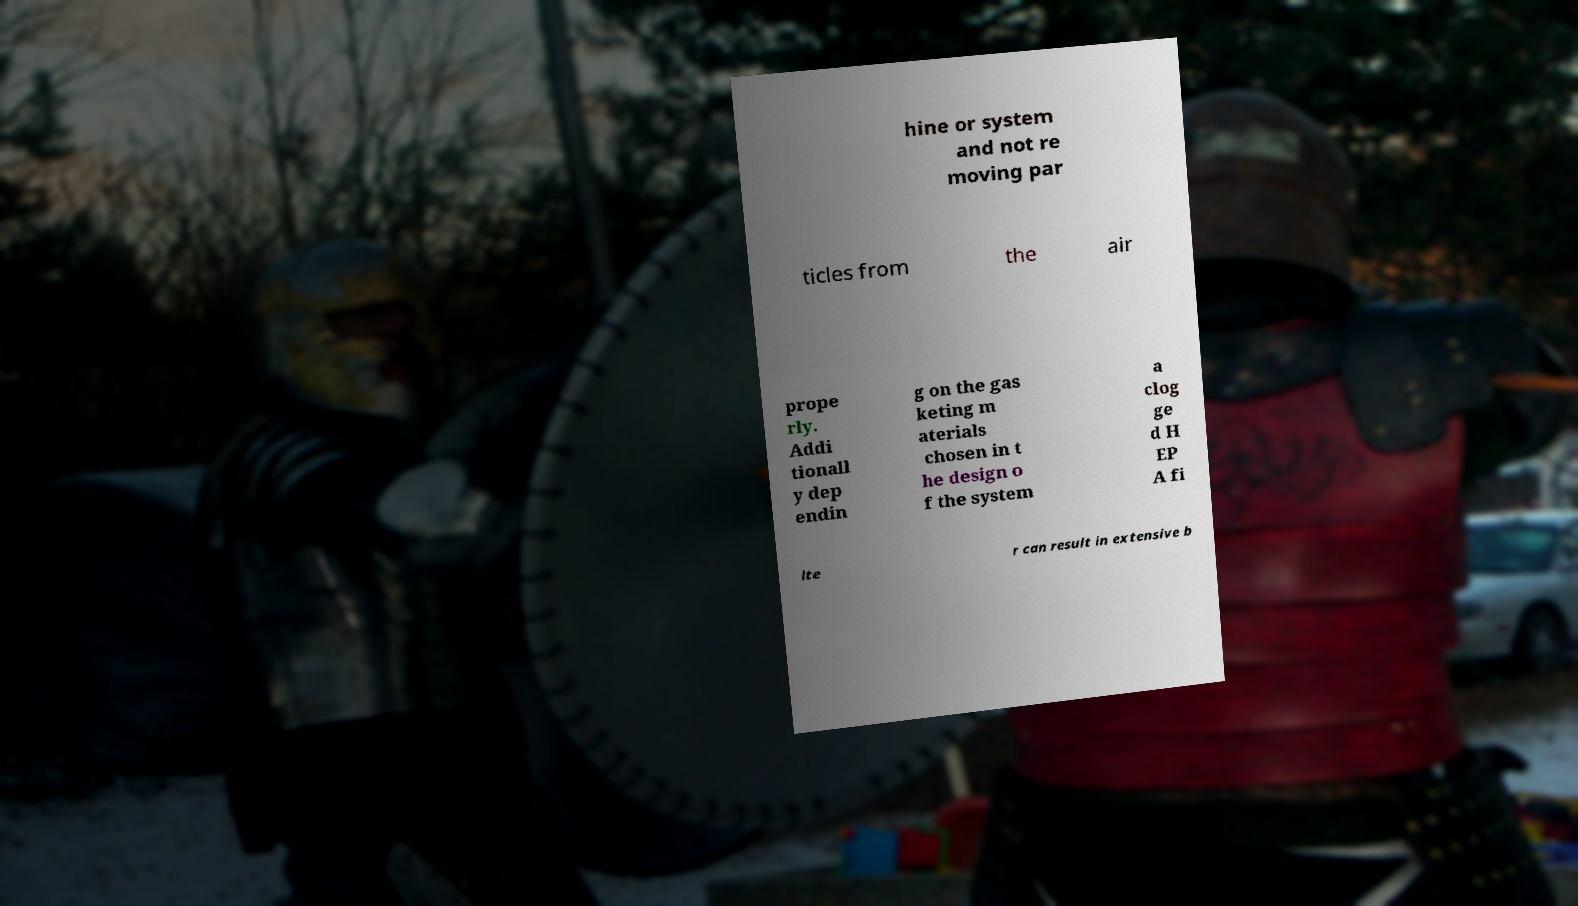What messages or text are displayed in this image? I need them in a readable, typed format. hine or system and not re moving par ticles from the air prope rly. Addi tionall y dep endin g on the gas keting m aterials chosen in t he design o f the system a clog ge d H EP A fi lte r can result in extensive b 